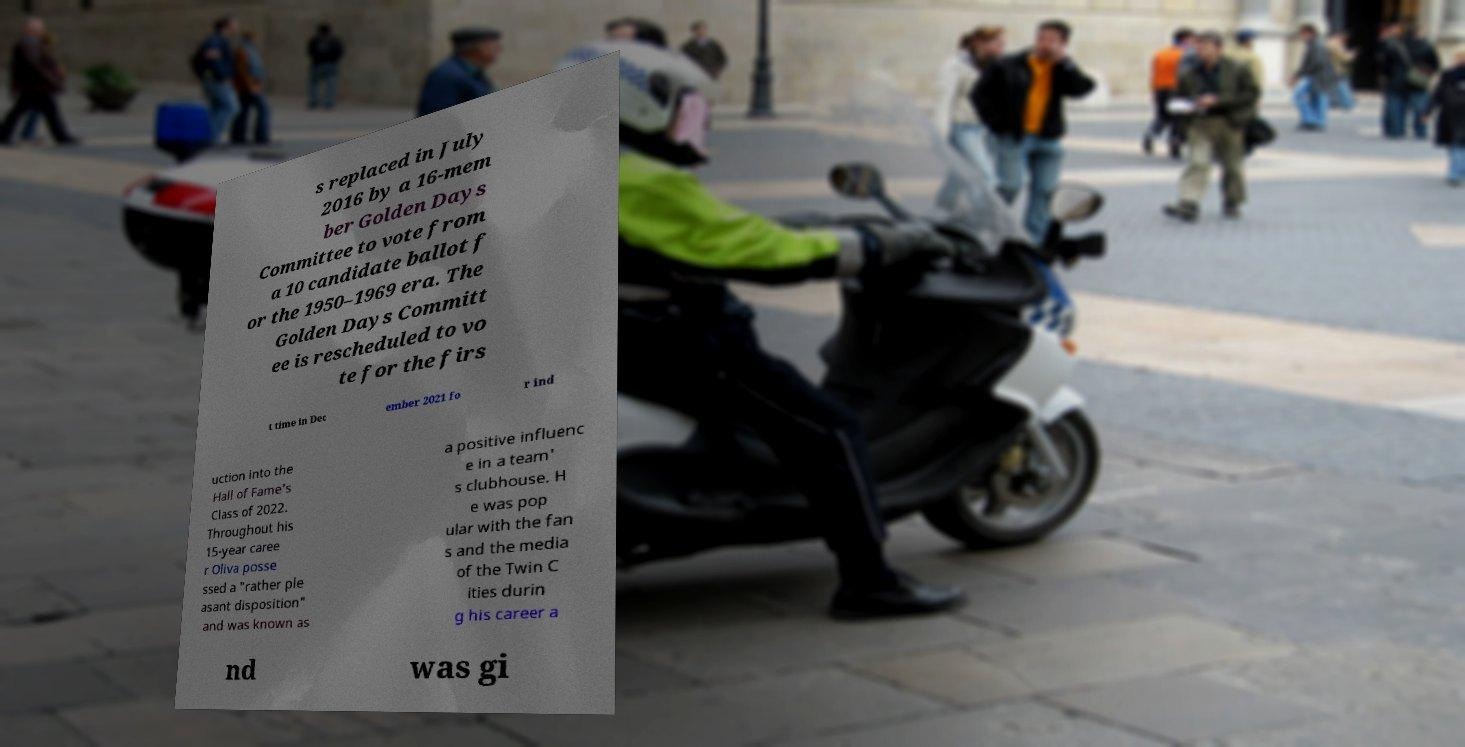Please identify and transcribe the text found in this image. s replaced in July 2016 by a 16-mem ber Golden Days Committee to vote from a 10 candidate ballot f or the 1950–1969 era. The Golden Days Committ ee is rescheduled to vo te for the firs t time in Dec ember 2021 fo r ind uction into the Hall of Fame's Class of 2022. Throughout his 15-year caree r Oliva posse ssed a "rather ple asant disposition" and was known as a positive influenc e in a team' s clubhouse. H e was pop ular with the fan s and the media of the Twin C ities durin g his career a nd was gi 